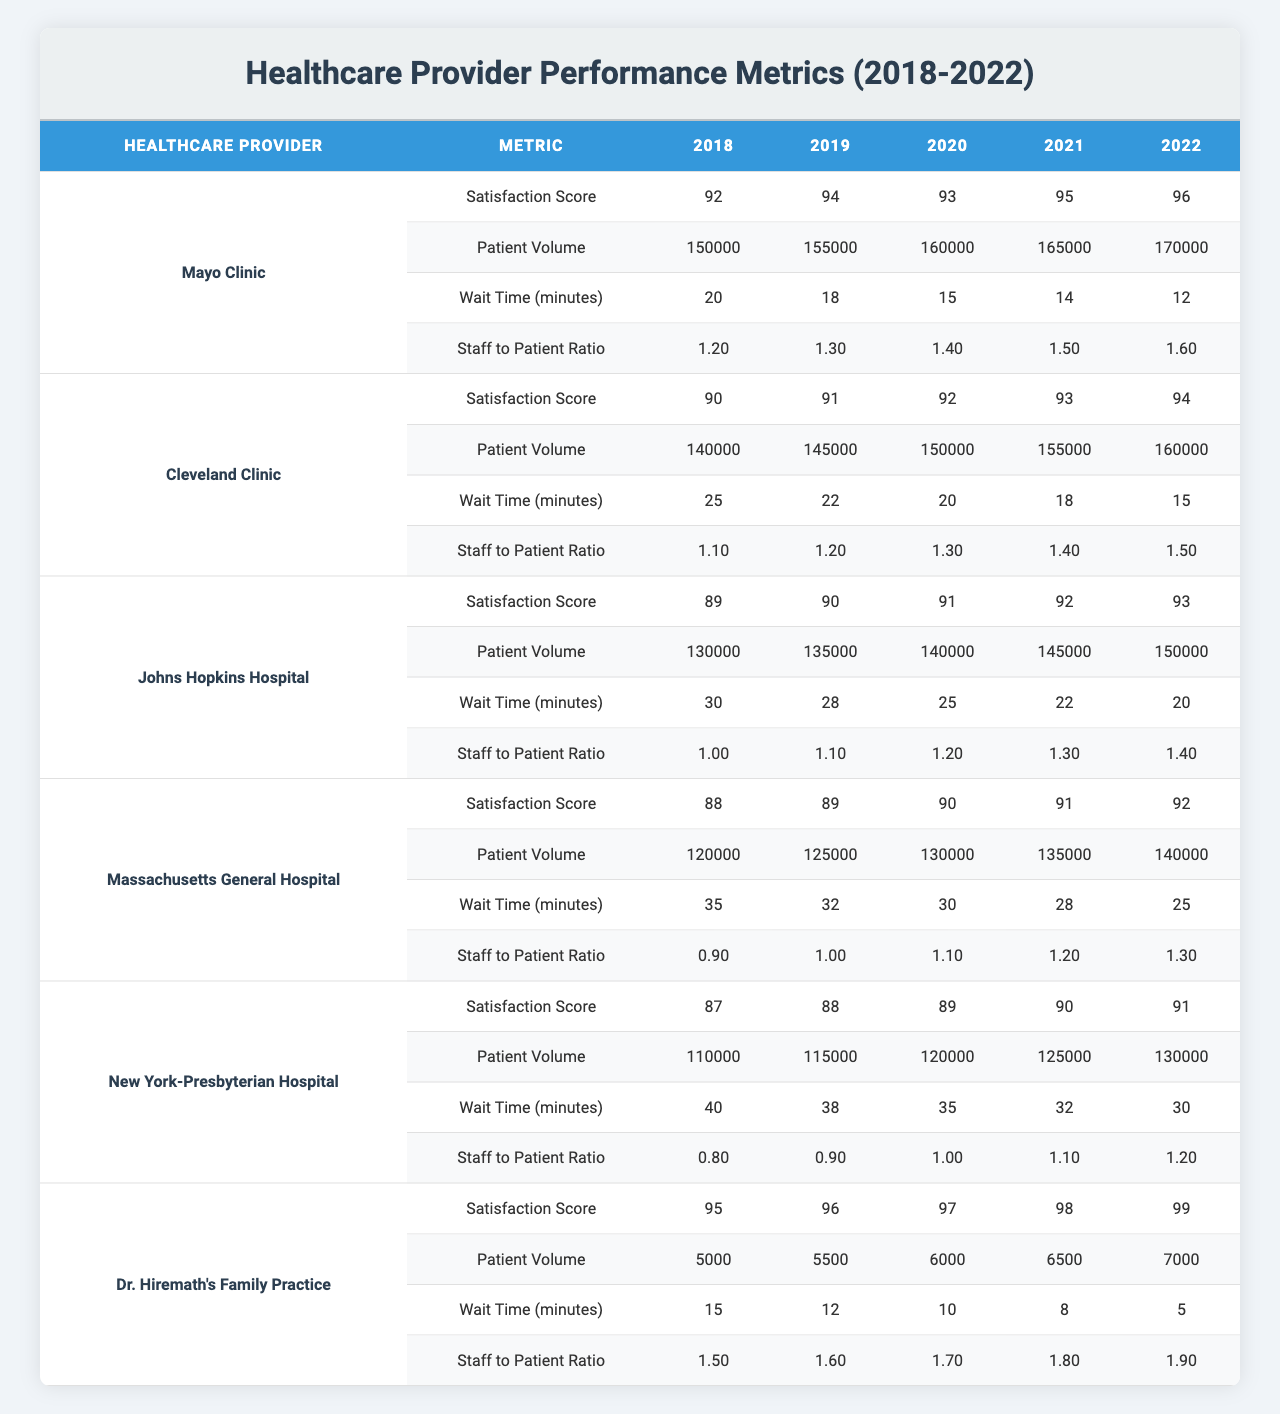What is the satisfaction score of Dr. Hiremath's Family Practice in 2022? The satisfaction score in 2022 for Dr. Hiremath's Family Practice can be found in the table under the "Satisfaction Score" row for that provider, which is 99.
Answer: 99 What was the patient volume at the Cleveland Clinic in 2020? The patient volume for the Cleveland Clinic in 2020 is displayed in the "Patient Volume" row, which shows a value of 150,000.
Answer: 150,000 Which healthcare provider had the highest satisfaction score in 2019? By comparing the satisfaction scores across providers for 2019, Dr. Hiremath's Family Practice had a score of 96, which is the highest among all listed providers.
Answer: Dr. Hiremath's Family Practice What is the average staff to patient ratio for Johns Hopkins Hospital from 2018 to 2022? The staff to patient ratios for Johns Hopkins Hospital are 1.0, 1.1, 1.2, 1.3, and 1.4 over the five years. The sum is 1.0 + 1.1 + 1.2 + 1.3 + 1.4 = 6.0. Dividing by 5, the average is 6.0 / 5 = 1.2.
Answer: 1.2 Was the wait time for New York-Presbyterian Hospital lower than the average wait time for Massachusetts General Hospital in 2021? The wait time for New York-Presbyterian Hospital in 2021 is 32 minutes, while the wait time for Massachusetts General Hospital is 28 minutes. Since 32 is greater than 28, the statement is false.
Answer: No What is the trend of satisfaction scores for the Mayo Clinic from 2018 to 2022? Looking at the satisfaction scores for Mayo Clinic over these years: 92, 94, 93, 95, and 96, we can see an increasing trend with some fluctuation between 2018 and 2022 but generally improving over the years.
Answer: Increasing trend Which provider had the second-lowest patient volume in 2022? Reviewing the patient volumes, Dr. Hiremath's Family Practice had 7,000 patients, while New York-Presbyterian Hospital had 130,000 in 2022. The second-lowest is New York-Presbyterian Hospital.
Answer: New York-Presbyterian Hospital Did the staff to patient ratio of Dr. Hiremath's Family Practice increase over the years? The staff to patient ratio for Dr. Hiremath's Family Practice in 2018 was 1.5, increasing to 1.9 in 2022. Since the values consistently increased from 1.5 to 1.9, the answer is yes.
Answer: Yes What is the difference between the highest and lowest satisfaction scores in 2020? The highest satisfaction score in 2020 is for Dr. Hiremath's Family Practice at 97, while the lowest is for Johns Hopkins Hospital at 91. The difference is 97 - 91 = 6.
Answer: 6 How much did the patient volume at the Mayo Clinic increase from 2018 to 2022? The patient volume at the Mayo Clinic increased from 150,000 in 2018 to 170,000 in 2022. The increase is 170,000 - 150,000 = 20,000.
Answer: 20,000 